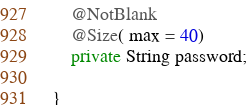<code> <loc_0><loc_0><loc_500><loc_500><_Java_>
    @NotBlank
    @Size( max = 40)
    private String password;

}
</code> 